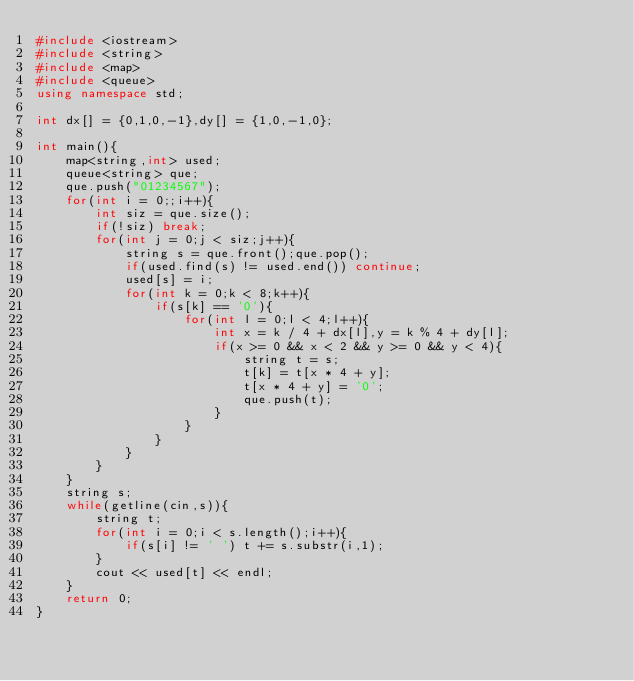Convert code to text. <code><loc_0><loc_0><loc_500><loc_500><_C++_>#include <iostream>
#include <string>
#include <map>
#include <queue>
using namespace std;

int dx[] = {0,1,0,-1},dy[] = {1,0,-1,0};

int main(){
	map<string,int> used;
	queue<string> que;
	que.push("01234567");
	for(int i = 0;;i++){
		int siz = que.size();
		if(!siz) break;
		for(int j = 0;j < siz;j++){
			string s = que.front();que.pop();
			if(used.find(s) != used.end()) continue;
			used[s] = i;
			for(int k = 0;k < 8;k++){
				if(s[k] == '0'){
					for(int l = 0;l < 4;l++){
						int x = k / 4 + dx[l],y = k % 4 + dy[l];
						if(x >= 0 && x < 2 && y >= 0 && y < 4){
							string t = s;
							t[k] = t[x * 4 + y];
							t[x * 4 + y] = '0';
							que.push(t);
						}
					}
				}
			}
		}
	}
	string s;
	while(getline(cin,s)){
		string t;
		for(int i = 0;i < s.length();i++){
			if(s[i] != ' ') t += s.substr(i,1);
		}
		cout << used[t] << endl;
	}
	return 0;
}</code> 